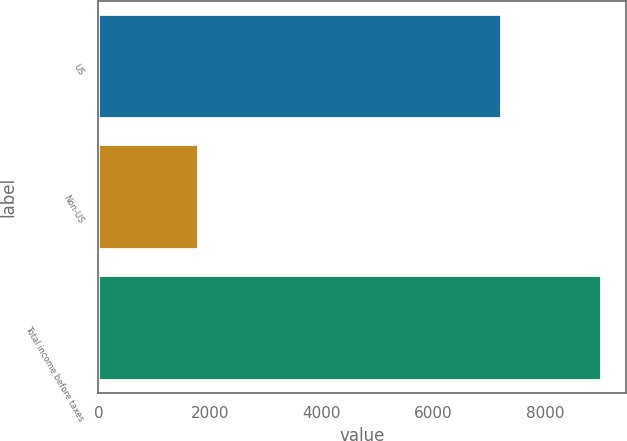<chart> <loc_0><loc_0><loc_500><loc_500><bar_chart><fcel>US<fcel>Non-US<fcel>Total income before taxes<nl><fcel>7214<fcel>1781<fcel>8995<nl></chart> 